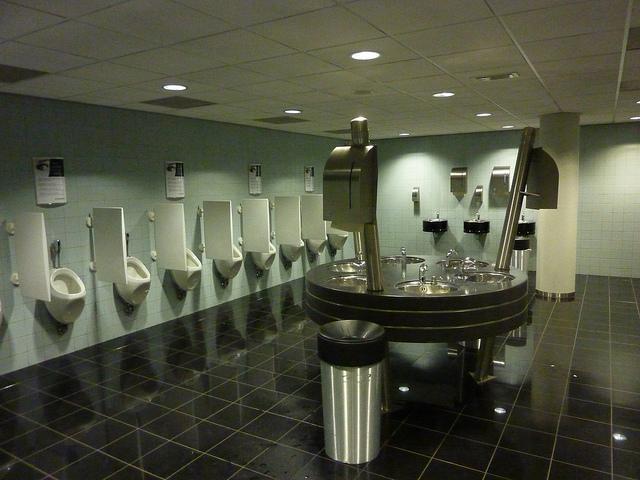How many chairs are there?
Give a very brief answer. 0. 